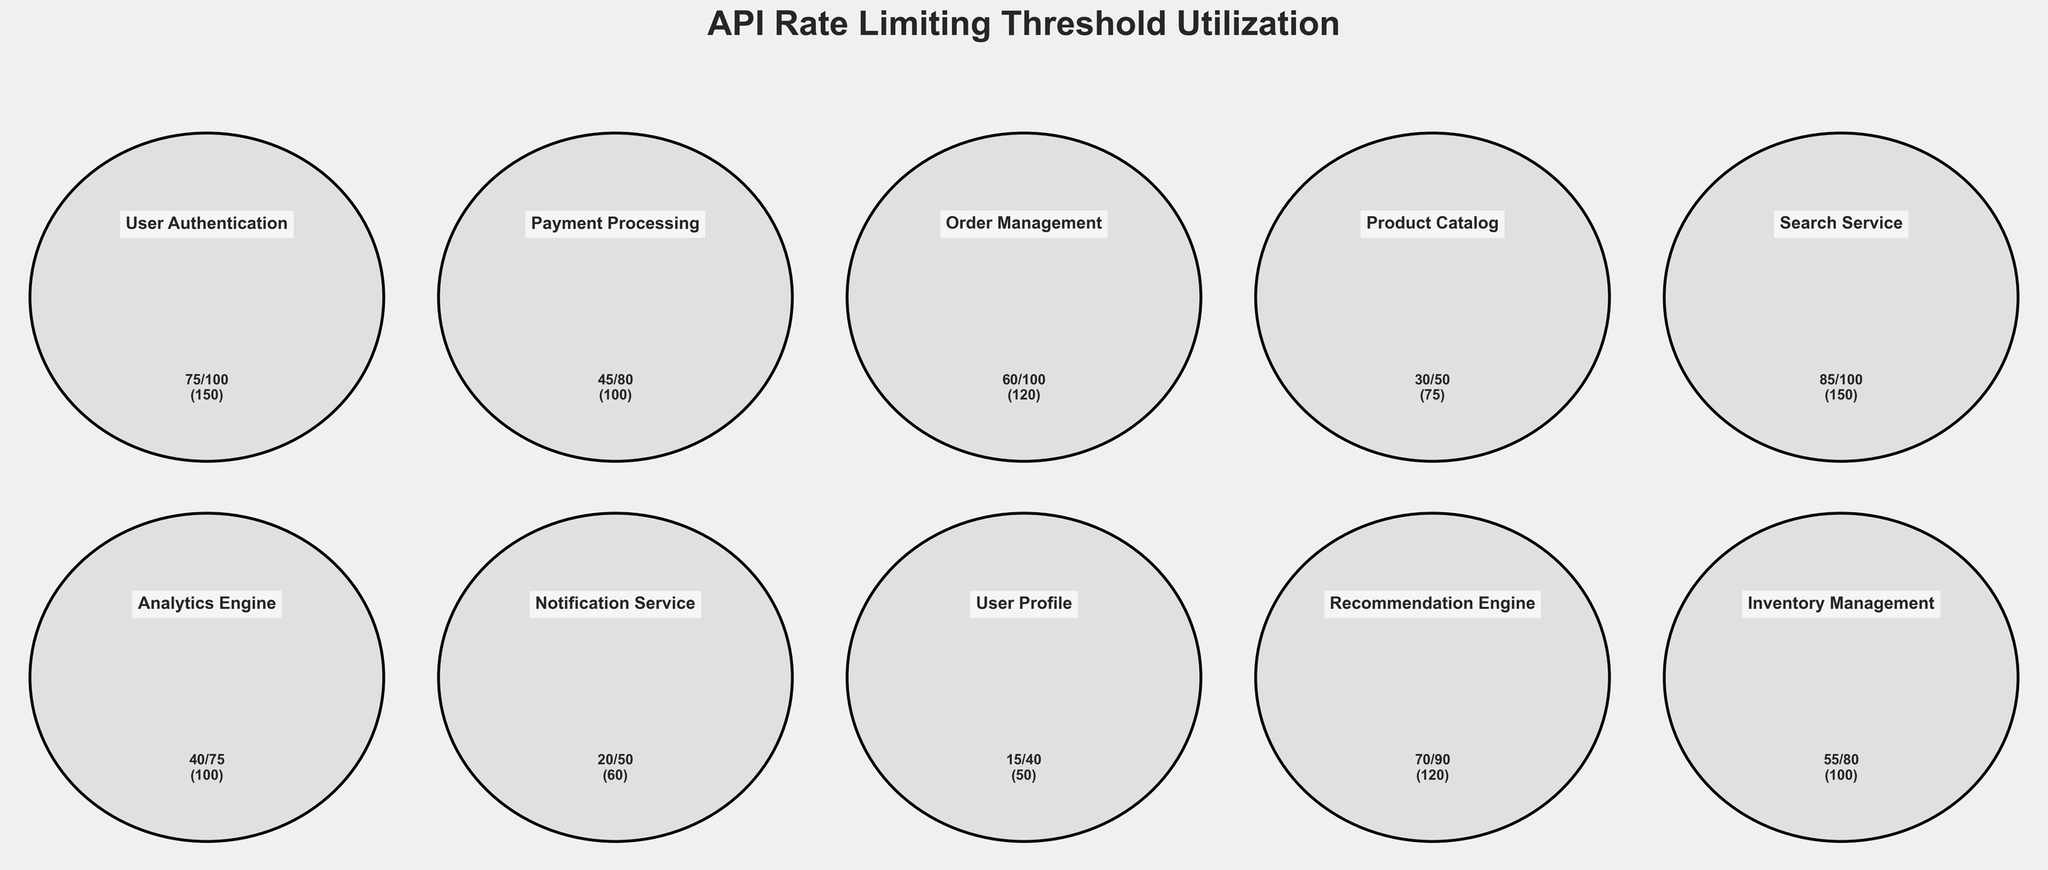How many API services are represented in the figure? The figure has 10 individual gauge charts, each representing a different API service. Count the gauges to determine the total number of represented API services.
Answer: 10 What is the title of the figure? The title of the figure is displayed prominently at the top and reads "API Rate Limiting Threshold Utilization." Read the top of the figure for the title.
Answer: API Rate Limiting Threshold Utilization Which API has the highest current usage? Review each gauge chart to identify the API with the highest percentage of the gauge filled. The Search Service gauge has the highest current usage with 85.
Answer: Search Service Which API has the lowest threshold value? Examine the threshold values indicated within each gauge chart. The User Profile API has the lowest threshold value, which is 40.
Answer: User Profile Which APIs have exceeded their current usage threshold? Compare the 'Current Usage' to the 'Threshold' for each API. APIs where 'Current Usage' > 'Threshold' have exceeded their threshold. The Search Service (85) is the only one exceeding its threshold (100).
Answer: Search Service What is the total current usage across all APIs? Sum the 'Current Usage' values for all APIs: 75 + 45 + 60 + 30 + 85 + 40 + 20 + 15 + 70 + 55 = 495.
Answer: 495 Which API is closest to reaching its maximum threshold without surpassing it? Look for APIs where 'Current Usage' is closest to 'Max Threshold' without exceeding it. The Search Service has 85 current usage out of 150 max threshold, which is relatively close but hasn't exceeded it.
Answer: Search Service What is the average threshold value across all the APIs? Calculate the average by summing all threshold values and dividing by the number of APIs: (100 + 80 + 100 + 50 + 100 + 75 + 50 + 40 + 90 + 80) / 10 = 77.5.
Answer: 77.5 Compare the Payment Processing and Notification Service in terms of their current usage ratio relative to the max threshold. Which API has a higher ratio? Calculate the ratio for each: Payment Processing (45/100 = 0.45), Notification Service (20/60 = 0.33). Payment Processing has a higher ratio.
Answer: Payment Processing Which three APIs have the highest threshold values, and what are these values? Identify the highest threshold values: User Authentication (100), Order Management (100), Search Service (100).
Answer: User Authentication, Order Management, Search Service 